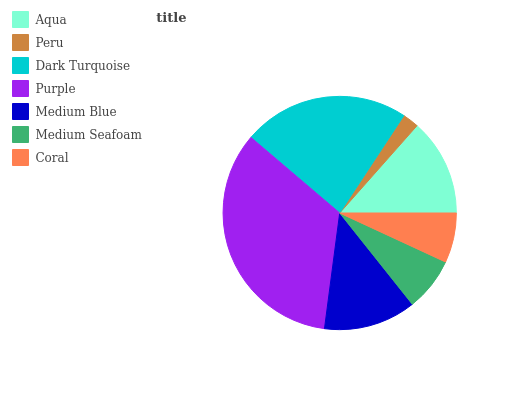Is Peru the minimum?
Answer yes or no. Yes. Is Purple the maximum?
Answer yes or no. Yes. Is Dark Turquoise the minimum?
Answer yes or no. No. Is Dark Turquoise the maximum?
Answer yes or no. No. Is Dark Turquoise greater than Peru?
Answer yes or no. Yes. Is Peru less than Dark Turquoise?
Answer yes or no. Yes. Is Peru greater than Dark Turquoise?
Answer yes or no. No. Is Dark Turquoise less than Peru?
Answer yes or no. No. Is Medium Blue the high median?
Answer yes or no. Yes. Is Medium Blue the low median?
Answer yes or no. Yes. Is Dark Turquoise the high median?
Answer yes or no. No. Is Peru the low median?
Answer yes or no. No. 